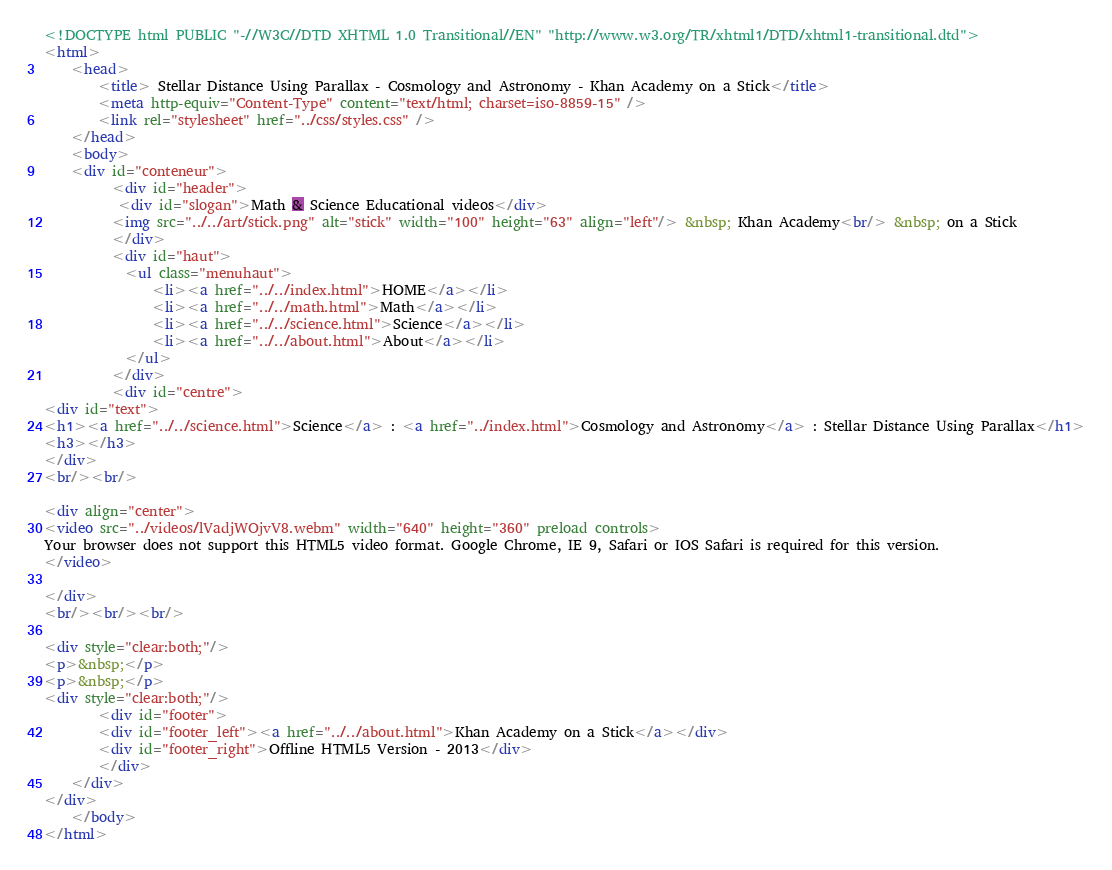<code> <loc_0><loc_0><loc_500><loc_500><_HTML_><!DOCTYPE html PUBLIC "-//W3C//DTD XHTML 1.0 Transitional//EN" "http://www.w3.org/TR/xhtml1/DTD/xhtml1-transitional.dtd">
<html>
	<head>
		<title> Stellar Distance Using Parallax - Cosmology and Astronomy - Khan Academy on a Stick</title>
		<meta http-equiv="Content-Type" content="text/html; charset=iso-8859-15" />
		<link rel="stylesheet" href="../css/styles.css" />
	</head>
	<body>
	<div id="conteneur">
		  <div id="header">
		   <div id="slogan">Math & Science Educational videos</div>
		  <img src="../../art/stick.png" alt="stick" width="100" height="63" align="left"/> &nbsp; Khan Academy<br/> &nbsp; on a Stick
		  </div>
		  <div id="haut">
			<ul class="menuhaut">
				<li><a href="../../index.html">HOME</a></li>
				<li><a href="../../math.html">Math</a></li>
				<li><a href="../../science.html">Science</a></li>
				<li><a href="../../about.html">About</a></li>
			</ul>
		  </div>
		  <div id="centre">
<div id="text">
<h1><a href="../../science.html">Science</a> : <a href="../index.html">Cosmology and Astronomy</a> : Stellar Distance Using Parallax</h1>
<h3></h3>
</div>
<br/><br/>

<div align="center">
<video src="../videos/lVadjWOjvV8.webm" width="640" height="360" preload controls>
Your browser does not support this HTML5 video format. Google Chrome, IE 9, Safari or IOS Safari is required for this version.
</video> 

</div>
<br/><br/><br/>

<div style="clear:both;"/>
<p>&nbsp;</p>
<p>&nbsp;</p>						
<div style="clear:both;"/>		
		<div id="footer">
		<div id="footer_left"><a href="../../about.html">Khan Academy on a Stick</a></div>
		<div id="footer_right">Offline HTML5 Version - 2013</div>
		</div>
	</div>
</div>	
	</body>
</html>
</code> 